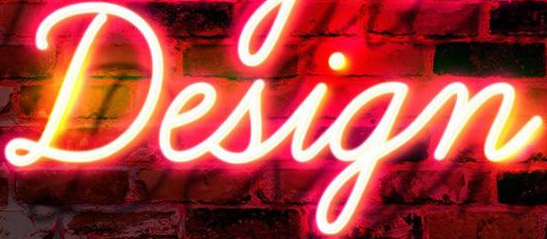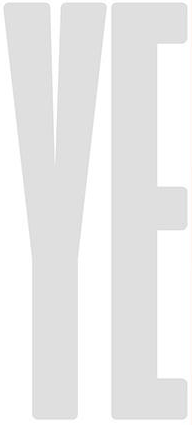What words are shown in these images in order, separated by a semicolon? Design; YE 